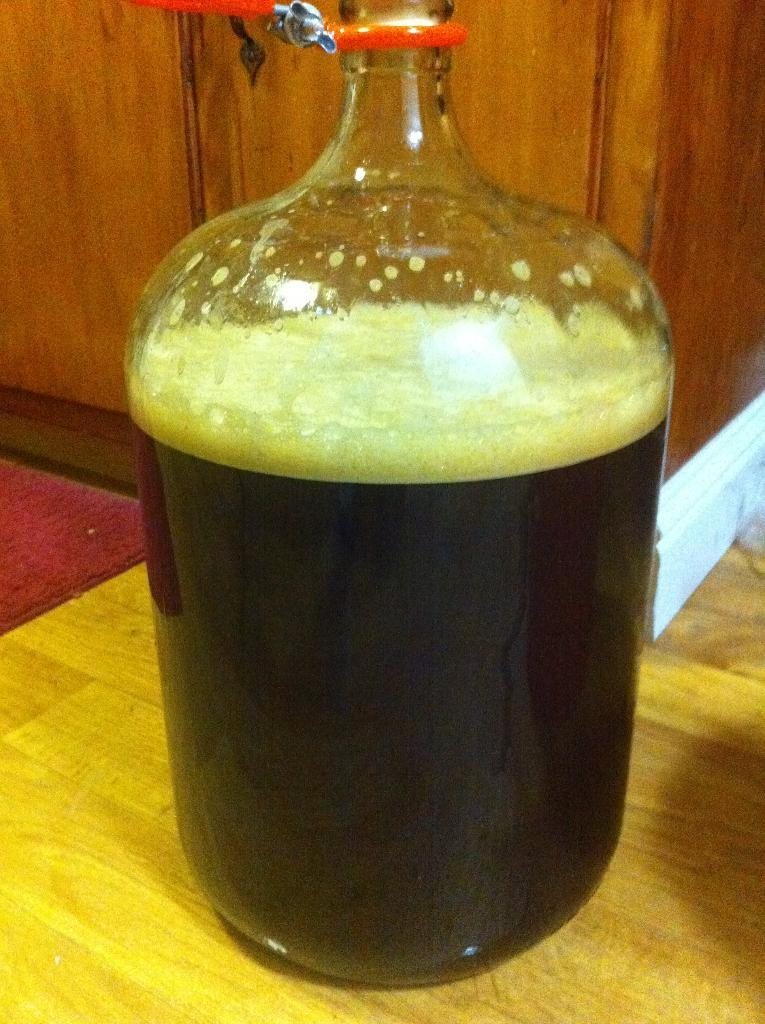What object is on the table in the image? There is a flask on a table in the image. What is inside the flask? The flask contains a liquid. What is the color of the liquid in the flask? The liquid is black in color. What is located on the floor in the image? There is a floor mat in the image. What is the color of the floor mat? The floor mat is red in color. What decision does the authority make in the image? There is no authority figure or decision-making process depicted in the image; it only shows a flask on a table and a red floor mat. 